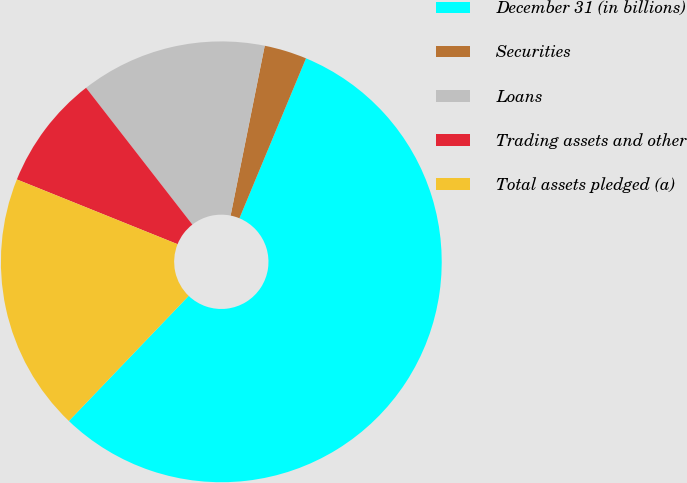Convert chart. <chart><loc_0><loc_0><loc_500><loc_500><pie_chart><fcel>December 31 (in billions)<fcel>Securities<fcel>Loans<fcel>Trading assets and other<fcel>Total assets pledged (a)<nl><fcel>55.88%<fcel>3.12%<fcel>13.67%<fcel>8.39%<fcel>18.94%<nl></chart> 